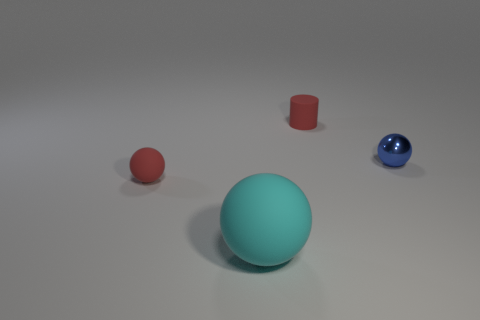Add 3 big brown blocks. How many objects exist? 7 Subtract all tiny balls. How many balls are left? 1 Subtract all red balls. How many balls are left? 2 Subtract all brown cylinders. How many cyan balls are left? 1 Add 2 large rubber spheres. How many large rubber spheres are left? 3 Add 3 tiny yellow metal cylinders. How many tiny yellow metal cylinders exist? 3 Subtract 0 purple cylinders. How many objects are left? 4 Subtract all cylinders. How many objects are left? 3 Subtract 1 cylinders. How many cylinders are left? 0 Subtract all brown cylinders. Subtract all gray balls. How many cylinders are left? 1 